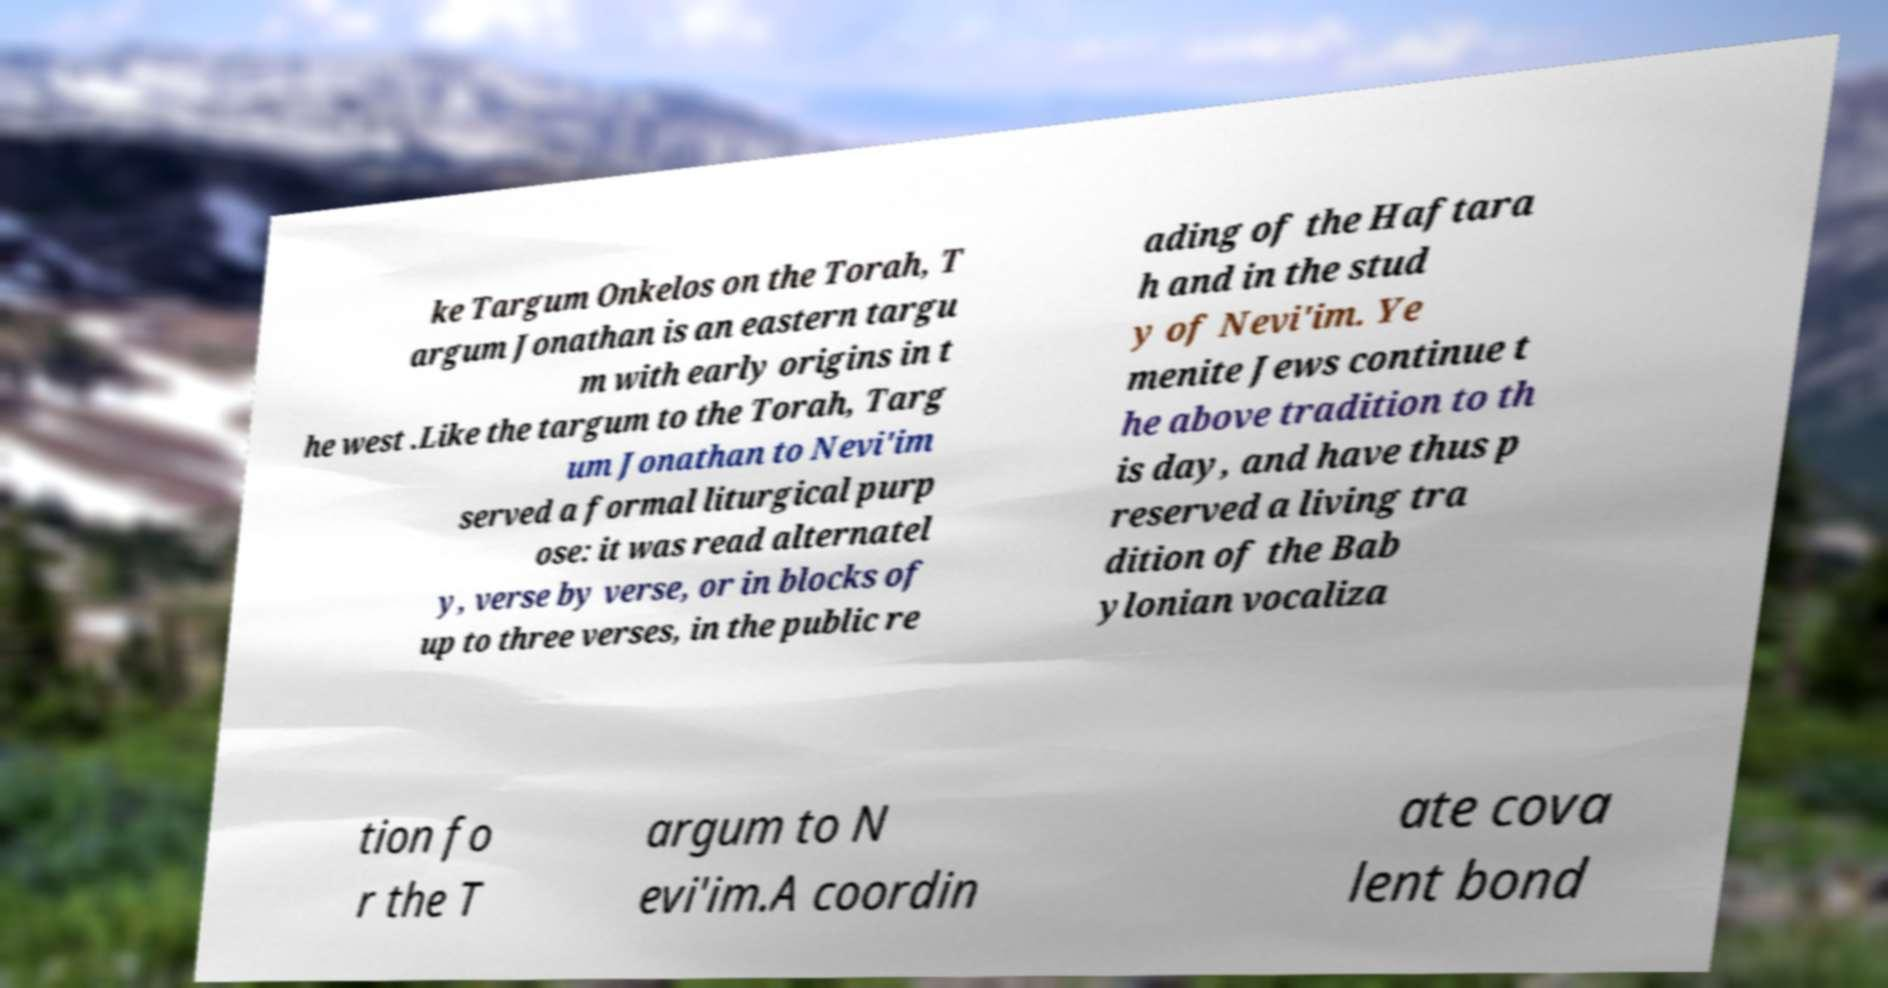I need the written content from this picture converted into text. Can you do that? ke Targum Onkelos on the Torah, T argum Jonathan is an eastern targu m with early origins in t he west .Like the targum to the Torah, Targ um Jonathan to Nevi'im served a formal liturgical purp ose: it was read alternatel y, verse by verse, or in blocks of up to three verses, in the public re ading of the Haftara h and in the stud y of Nevi'im. Ye menite Jews continue t he above tradition to th is day, and have thus p reserved a living tra dition of the Bab ylonian vocaliza tion fo r the T argum to N evi'im.A coordin ate cova lent bond 